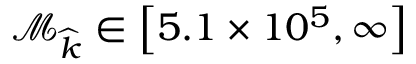Convert formula to latex. <formula><loc_0><loc_0><loc_500><loc_500>\mathcal { M } _ { \widehat { k } } \in \left [ 5 . 1 \times 1 0 ^ { 5 } , \infty \right ]</formula> 